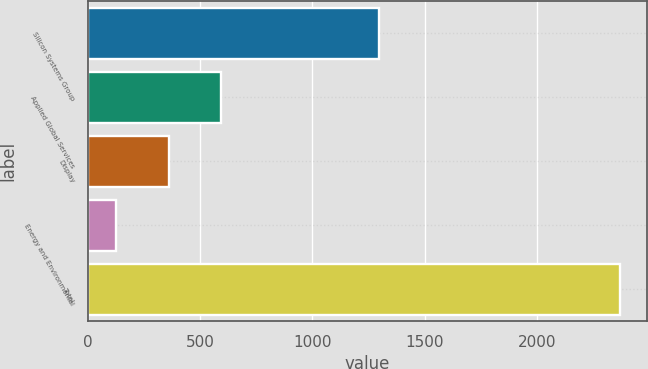<chart> <loc_0><loc_0><loc_500><loc_500><bar_chart><fcel>Silicon Systems Group<fcel>Applied Global Services<fcel>Display<fcel>Energy and Environmental<fcel>Total<nl><fcel>1295<fcel>591<fcel>361<fcel>125<fcel>2372<nl></chart> 